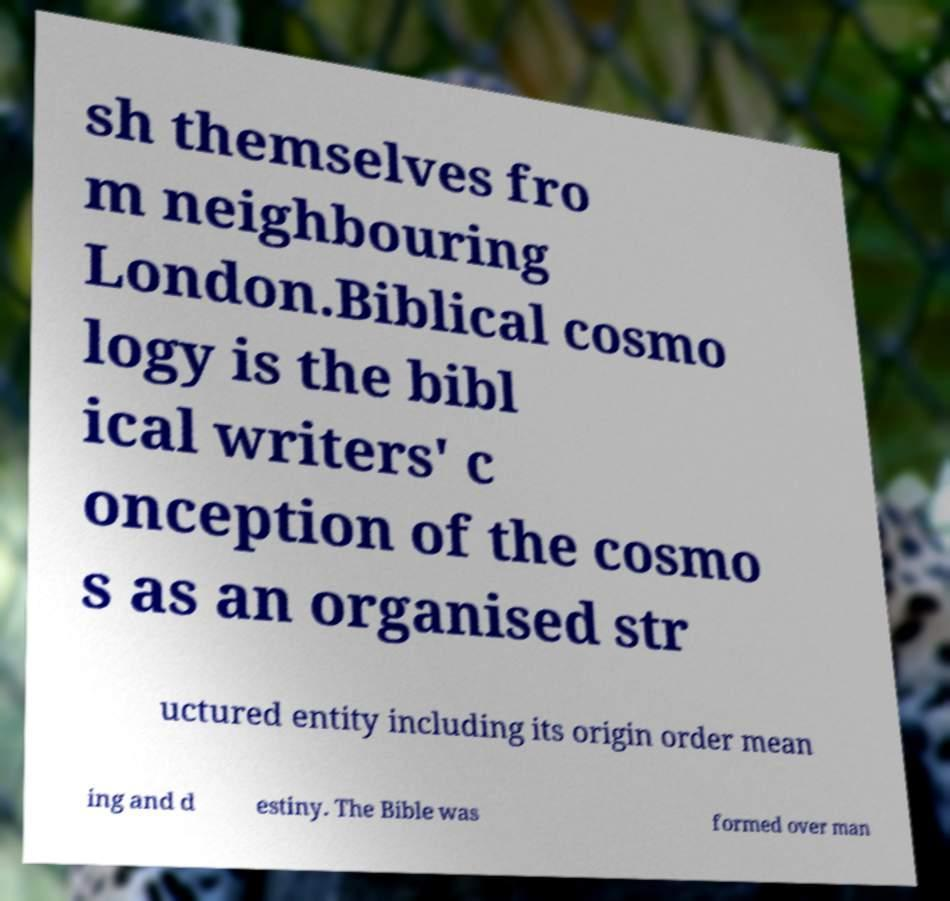Can you accurately transcribe the text from the provided image for me? sh themselves fro m neighbouring London.Biblical cosmo logy is the bibl ical writers' c onception of the cosmo s as an organised str uctured entity including its origin order mean ing and d estiny. The Bible was formed over man 